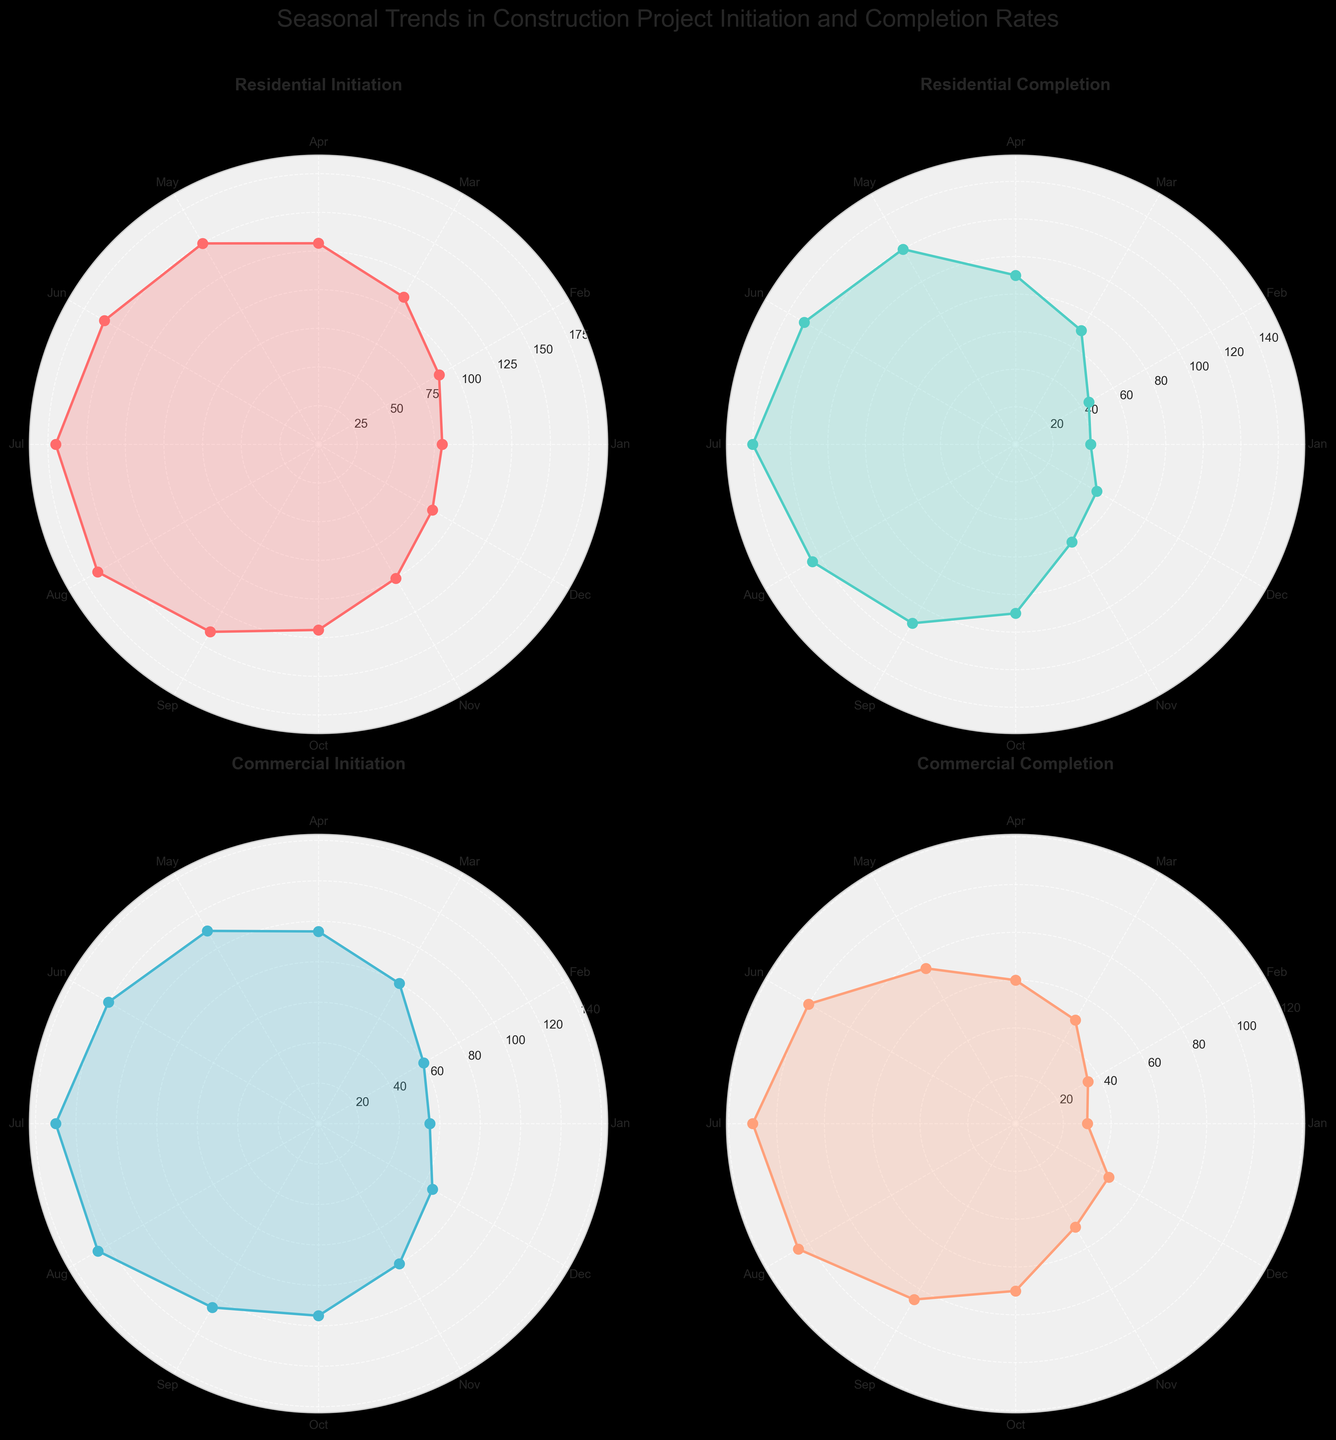What's the title of the subplot at the top left? The subplot at the top left corner shows the 'Residential Initiation' rates. This can be identified by looking at the title placed above the plots.
Answer: Residential Initiation How many months show residential initiation rates higher than 150? From the 'Residential Initiation' subplot, data points at months "Jun" (160) and "Jul" (170) have initiation rates higher than 150.
Answer: 2 Which month has the highest commercial initiation rate? Looking at the 'Commercial Initiation' subplot, the highest value is in "Jul" with 130.
Answer: July In which month are residential completion rates and commercial completion rates equal? Both the 'Residential Completion' and 'Commercial Completion' subplots show the same value of 50 for "Mar."
Answer: March What is the noticeable trend between initiation and completion rates in commercial projects from July to September? Observing the plots for both initiation and completion of commercial projects, initiation rates decrease from 130 to 105, and completion rates slightly decrease from 110 to 85. This indicates a general decline.
Answer: Decline Are the initiation rates for residential projects consistently increasing each month? By analyzing the 'Residential Initiation' plot, initiation rates initially increase each month until July (peak at 170) and then start to decline.
Answer: No What's the difference between the highest and lowest residential completion rates? The highest completion rate for residential projects is 140 in July, and the lowest is 40 in January. The difference is 140 - 40 = 100.
Answer: 100 During which months do commercial completion rates exceed 100? From the 'Commercial Completion' subplot, the months with rates exceeding 100 are "Jun" (100) and "Jul" (110).
Answer: July How does the trend of residential completion rates compare to commercial initiation rates? By comparing the 'Residential Completion' and 'Commercial Initiation' plots, the rates of commercial initiation generally increase till July and then drop, while residential completion steadily rises till Jul/Aug and then drops. Both follow a somewhat similar pattern but are not identical.
Answer: Similar pattern with differences 